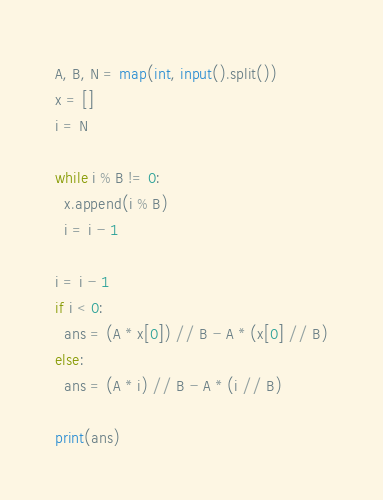Convert code to text. <code><loc_0><loc_0><loc_500><loc_500><_Python_>A, B, N = map(int, input().split())
x = []
i = N

while i % B != 0:
  x.append(i % B)
  i = i - 1
  
i = i - 1
if i < 0:
  ans = (A * x[0]) // B - A * (x[0] // B)
else:
  ans = (A * i) // B - A * (i // B)
  
print(ans)</code> 